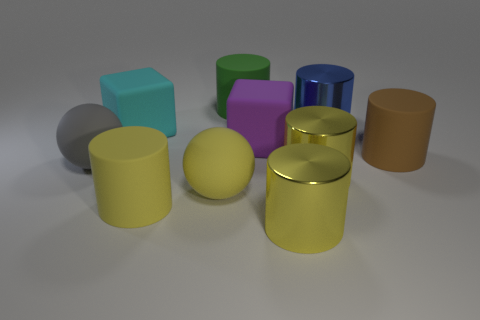Subtract all yellow spheres. How many yellow cylinders are left? 3 Subtract 1 cylinders. How many cylinders are left? 5 Subtract all blue cylinders. How many cylinders are left? 5 Subtract all green rubber cylinders. How many cylinders are left? 5 Subtract all purple cylinders. Subtract all green balls. How many cylinders are left? 6 Subtract all blocks. How many objects are left? 8 Add 5 blue objects. How many blue objects are left? 6 Add 5 large blue things. How many large blue things exist? 6 Subtract 0 blue blocks. How many objects are left? 10 Subtract all blue spheres. Subtract all purple objects. How many objects are left? 9 